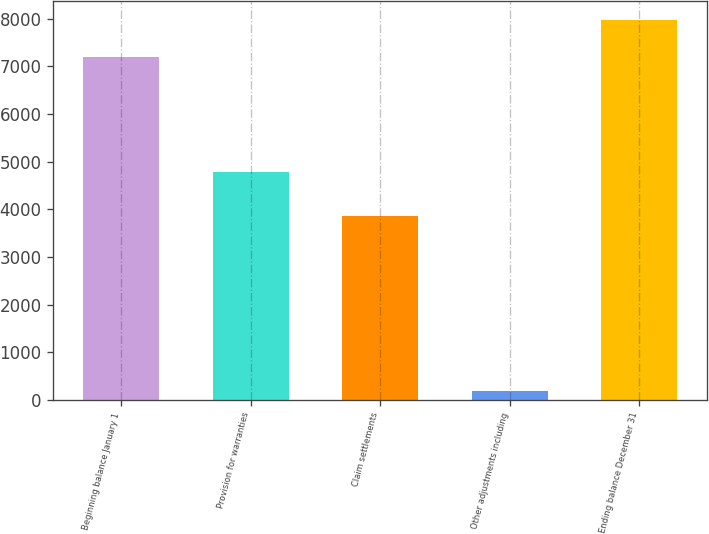Convert chart. <chart><loc_0><loc_0><loc_500><loc_500><bar_chart><fcel>Beginning balance January 1<fcel>Provision for warranties<fcel>Claim settlements<fcel>Other adjustments including<fcel>Ending balance December 31<nl><fcel>7196<fcel>4788<fcel>3864<fcel>184<fcel>7971.2<nl></chart> 